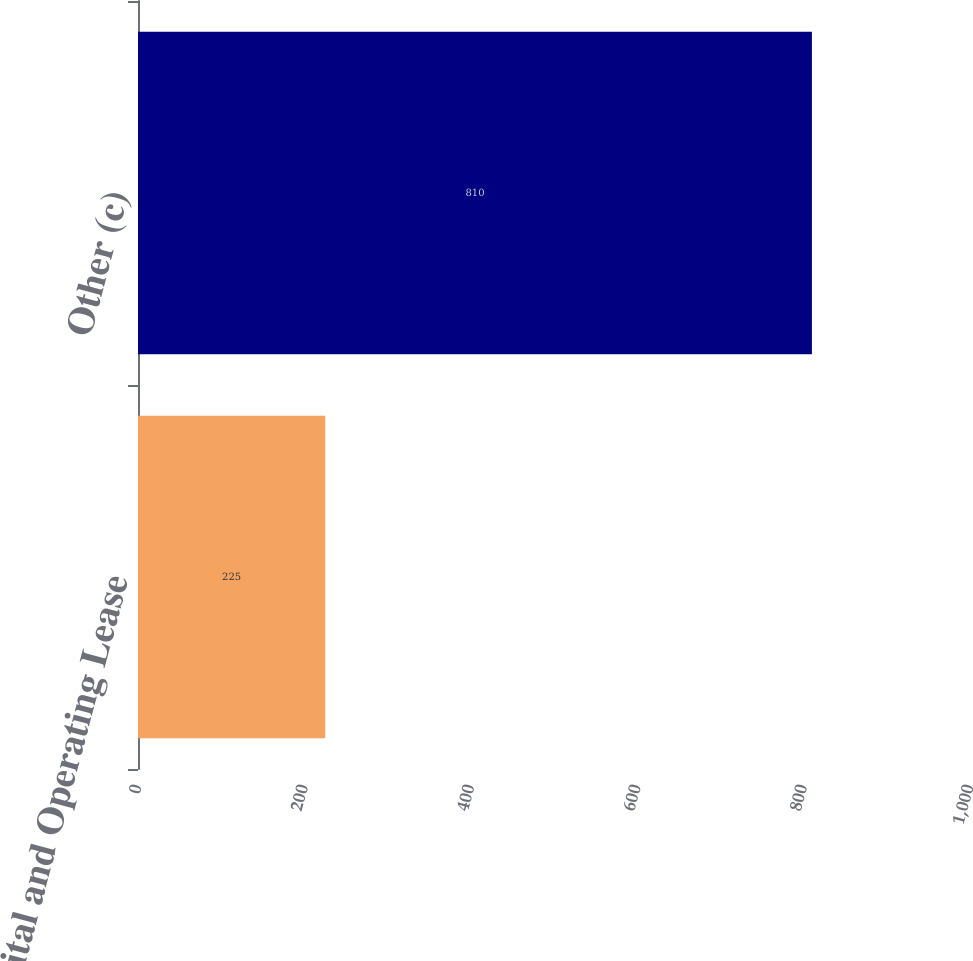Convert chart to OTSL. <chart><loc_0><loc_0><loc_500><loc_500><bar_chart><fcel>Capital and Operating Lease<fcel>Other (c)<nl><fcel>225<fcel>810<nl></chart> 